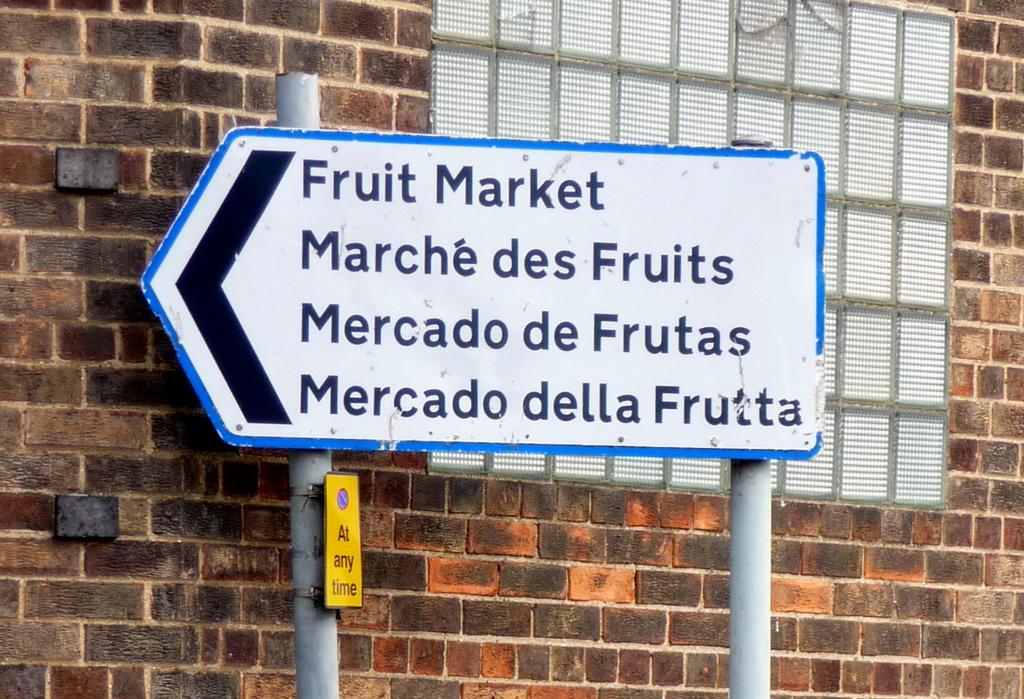Provide a one-sentence caption for the provided image. A sign hung against a brick wall shows the way to the fruit market. 